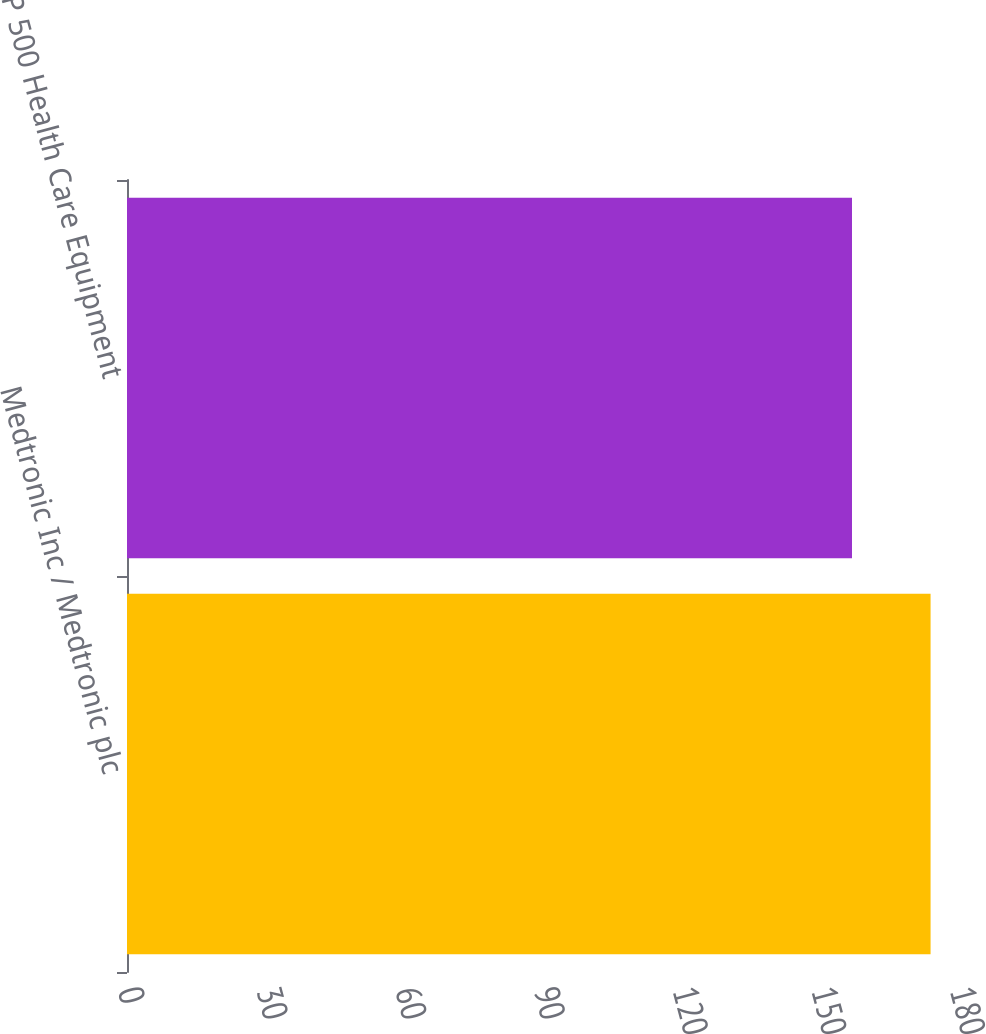<chart> <loc_0><loc_0><loc_500><loc_500><bar_chart><fcel>Medtronic Inc / Medtronic plc<fcel>S&P 500 Health Care Equipment<nl><fcel>173.85<fcel>156.85<nl></chart> 